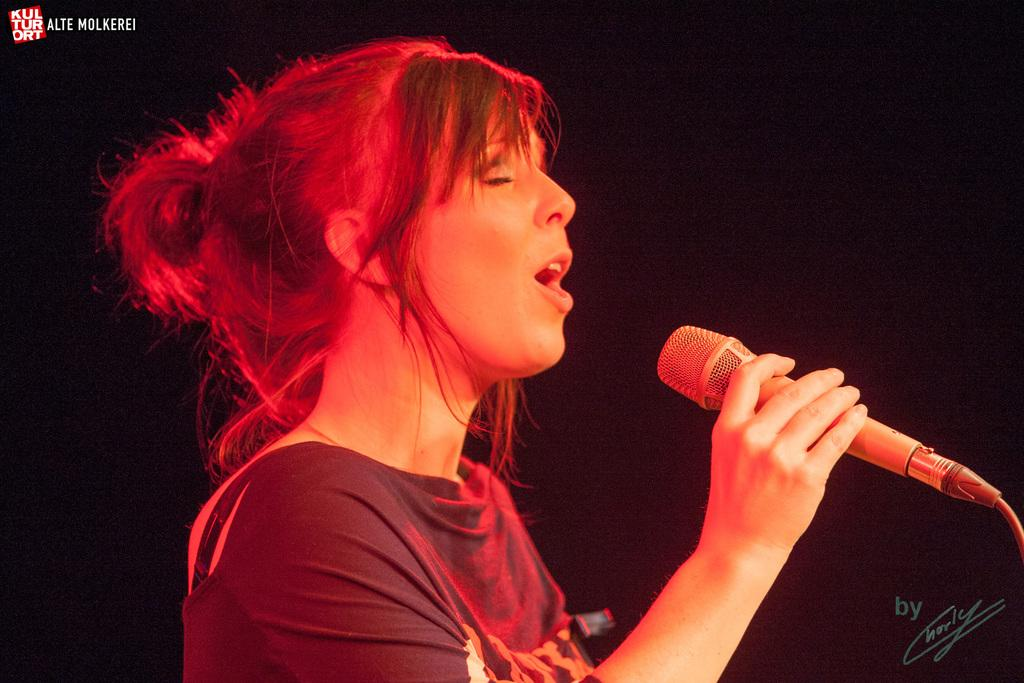What is the main subject of the image? The main subject of the image is a woman. Where is the woman positioned in the image? The woman is standing in the middle of the image. What is the woman holding in the image? The woman is holding a microphone. What is the woman doing in the image? The woman is singing. How does the woman get the attention of the audience in the image? The image does not show the woman getting the attention of the audience; it only shows her holding a microphone and singing. What type of motion is the woman performing in the image? The image does not depict any specific motion being performed by the woman; she is simply standing and singing. 